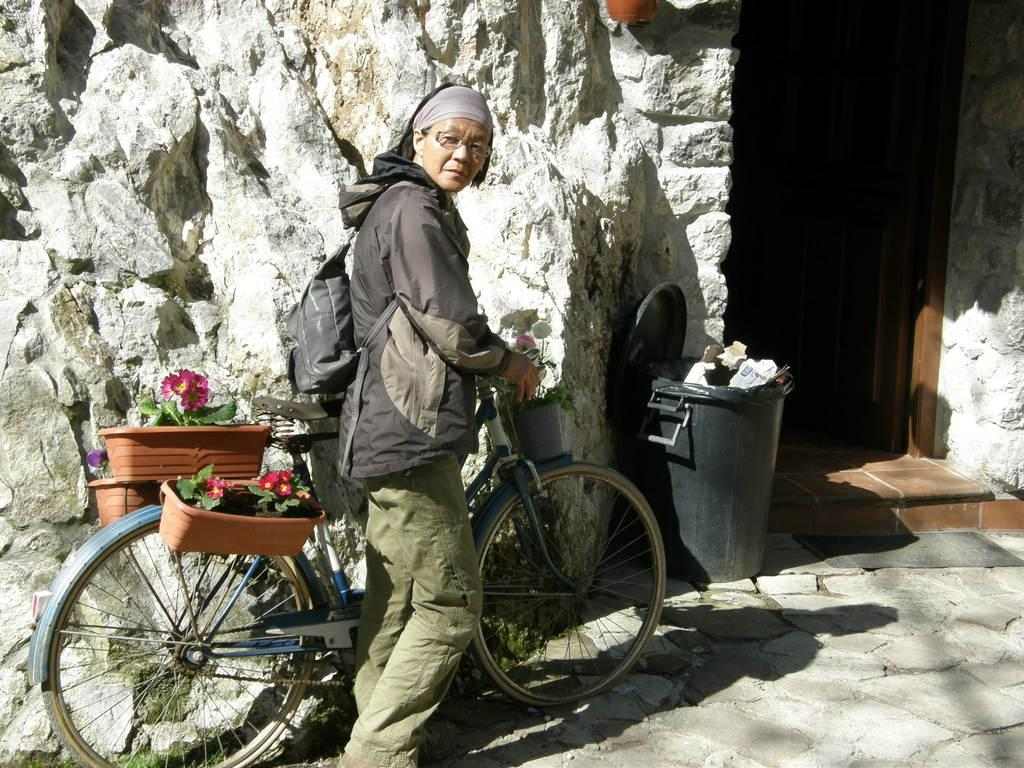Who is present in the image? There is a woman in the image. What is the woman holding in the image? The woman is holding a bicycle. Can you describe the bicycle in the image? The bicycle has flower plants on the back and front. What else is the woman carrying in the image? The woman is wearing a backpack. What else can be seen in the image? There is a dustbin visible in the image. What type of pest can be seen receiving treatment in the image? There is no pest or treatment present in the image. 